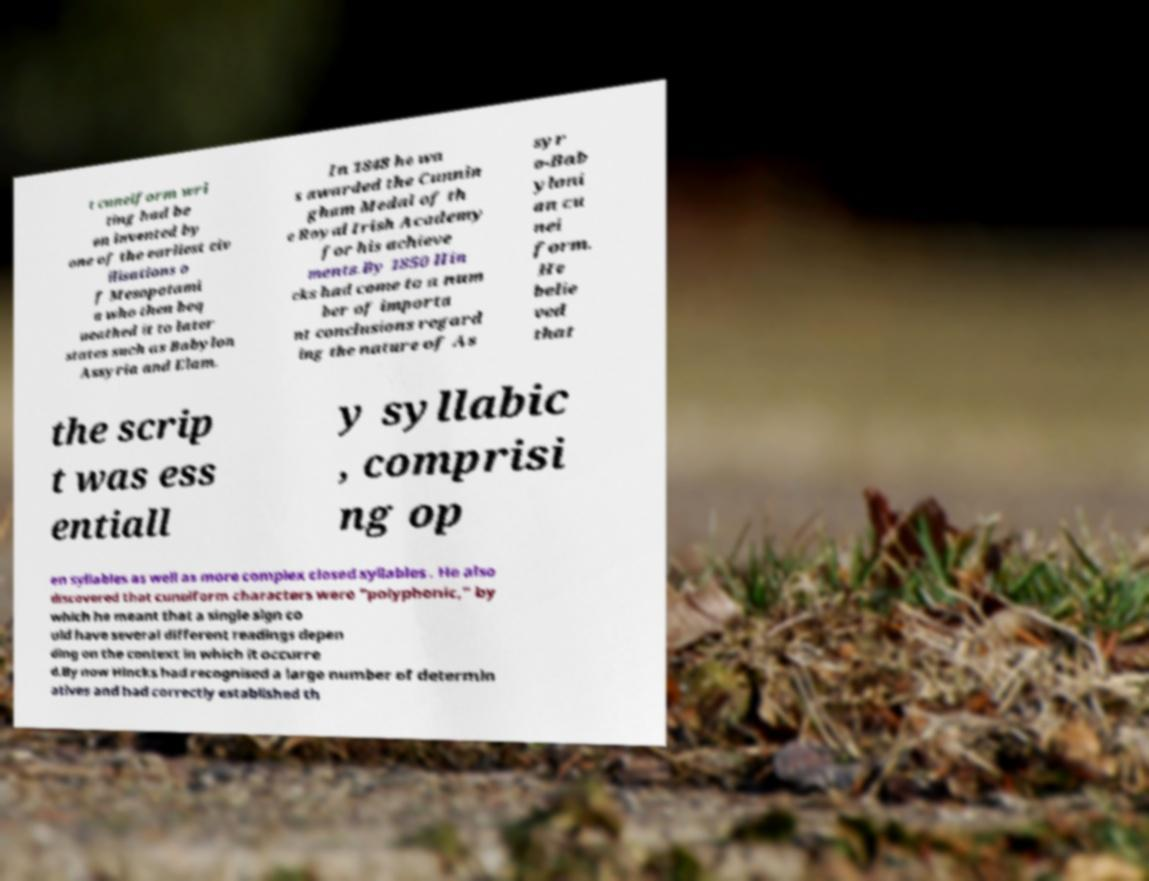For documentation purposes, I need the text within this image transcribed. Could you provide that? t cuneiform wri ting had be en invented by one of the earliest civ ilisations o f Mesopotami a who then beq ueathed it to later states such as Babylon Assyria and Elam. In 1848 he wa s awarded the Cunnin gham Medal of th e Royal Irish Academy for his achieve ments.By 1850 Hin cks had come to a num ber of importa nt conclusions regard ing the nature of As syr o-Bab yloni an cu nei form. He belie ved that the scrip t was ess entiall y syllabic , comprisi ng op en syllables as well as more complex closed syllables . He also discovered that cuneiform characters were "polyphonic," by which he meant that a single sign co uld have several different readings depen ding on the context in which it occurre d.By now Hincks had recognised a large number of determin atives and had correctly established th 